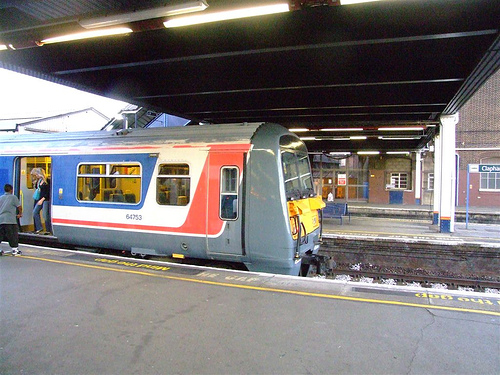What might the passengers on this train be feeling? While we can't ascertain individual emotions, passengers might typically feel a sense of anticipation for their journey or relief at having reached their destination. The station looks calm, so passengers might also feel at ease as they board or exit the train. 